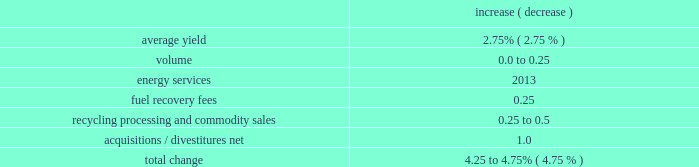Incremental contract start-up costs 2014large municipal contract .
During 2018 and 2017 , we incurred costs of $ 5.7 million and $ 8.2 million , respectively , related to the implementation of a large municipal contract .
These costs did not meet the capitalization criteria prescribed by the new revenue recognition standard .
Adoption of the tax act .
The tax act was enacted on december 22 , 2017 .
Among other things , the tax act reduced the u.s .
Federal corporate tax rate from 35% ( 35 % ) to 21% ( 21 % ) .
For the year ended december 31 , 2017 , we recorded provisional amounts based on our estimates of the tax act 2019s effect to our deferred taxes , uncertain tax positions , and one-time transition tax .
These adjustments reduced our tax provision by $ 463.9 million .
During 2018 , we adjusted the provisional amounts recorded as of december 31 , 2017 for the one-time transition tax , deferred taxes and uncertain tax positions .
These adjustments increased our tax provision by $ 0.3 million .
Bridgeton insurance recovery , net .
During 2018 , we collected an insurance recovery of $ 40.0 million related to our closed bridgeton landfill in missouri , which we recognized as a reduction of remediation expenses in our cost of operations .
In addition , we incurred $ 12.0 million of incremental costs attributable to the bridgeton insurance recovery .
Recent developments 2019 financial guidance in 2019 , we will continue to focus on managing the controllable aspects of our business by enhancing the quality of our revenue , investing in profitable growth opportunities and reducing costs .
Our team remains focused on executing our strategy to deliver consistent earnings and free cash flow growth , and improve return on invested capital .
We are committed to an efficient capital structure , maintaining our investment grade credit ratings and increasing cash returned to our shareholders .
Our guidance is based on current economic conditions and does not assume any significant changes in the overall economy in 2019 .
Specific guidance follows : revenue we expect 2019 revenue to increase by approximately 4.25 to 4.75% ( 4.75 % ) comprised of the following : increase ( decrease ) .
Changes in price are restricted on approximately 50% ( 50 % ) of our annual service revenue .
The majority of these restricted pricing arrangements are tied to fluctuations in a specific index ( primarily a consumer price index ) as defined in the contract .
The consumer price index varies from a single historical stated period of time or an average of trailing historical rates over a stated period of time .
In addition , the initial effect of pricing resets typically lags 6 to 12 months from the end of the index measurement period to the date the revised pricing goes into effect .
As a result , current changes in a specific index may not manifest themselves in our reported pricing for several quarters into the future. .
What is the ratio of the acquisitions / divestitures net to the fuel recovery fees as part of the expected 2019 revenue to increase? 
Computations: (1.0 / 0.25)
Answer: 4.0. 